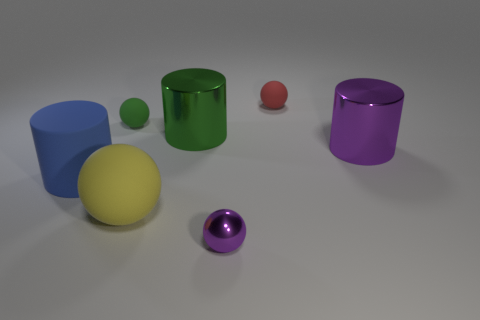How many cylinders are the same color as the large sphere?
Offer a terse response. 0. Are there an equal number of cylinders behind the blue cylinder and tiny purple matte objects?
Offer a very short reply. No. What color is the small metallic thing?
Make the answer very short. Purple. There is a cylinder that is the same material as the large green thing; what is its size?
Your response must be concise. Large. What is the color of the other large object that is made of the same material as the large blue object?
Give a very brief answer. Yellow. Is there a green thing that has the same size as the green sphere?
Provide a short and direct response. No. There is a tiny red object that is the same shape as the small green thing; what material is it?
Give a very brief answer. Rubber. There is a yellow thing that is the same size as the purple metallic cylinder; what shape is it?
Give a very brief answer. Sphere. Are there any green metallic things of the same shape as the blue rubber thing?
Offer a very short reply. Yes. There is a purple shiny thing behind the matte ball in front of the big rubber cylinder; what is its shape?
Your answer should be compact. Cylinder. 